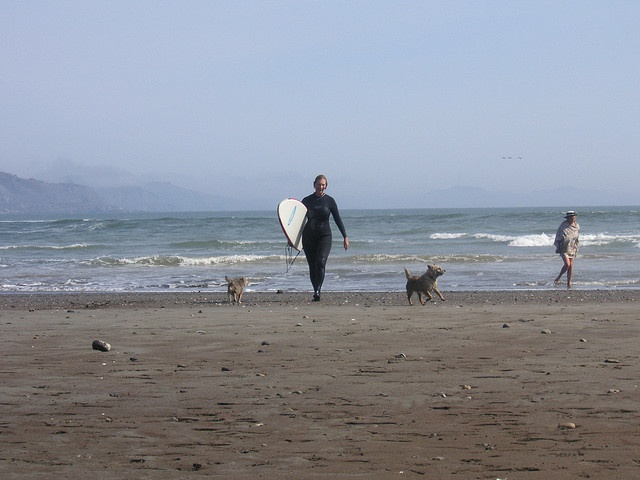Describe the objects in this image and their specific colors. I can see people in lavender, black, gray, and darkgray tones, people in lavender, gray, darkgray, black, and tan tones, surfboard in lavender, lightgray, gray, darkgray, and black tones, dog in lavender, black, gray, and darkgray tones, and dog in lavender, gray, darkgray, and black tones in this image. 